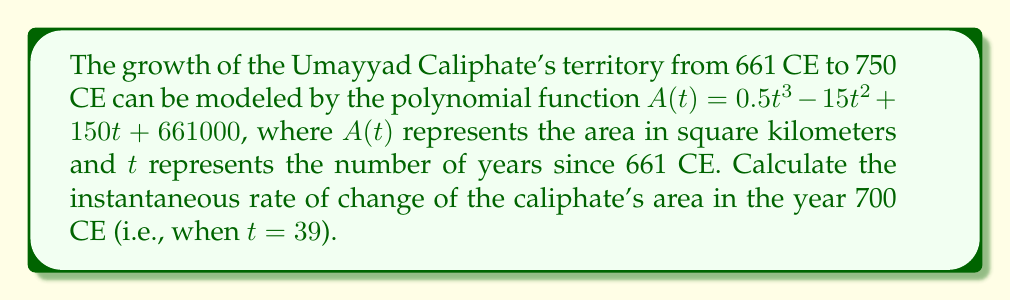Can you answer this question? To find the instantaneous rate of change at a specific point, we need to calculate the derivative of the function and evaluate it at the given point.

Step 1: Find the derivative of $A(t)$.
$$A'(t) = \frac{d}{dt}(0.5t^3 - 15t^2 + 150t + 661000)$$
$$A'(t) = 1.5t^2 - 30t + 150$$

Step 2: Evaluate $A'(t)$ at $t = 39$ (year 700 CE).
$$A'(39) = 1.5(39)^2 - 30(39) + 150$$
$$A'(39) = 1.5(1521) - 1170 + 150$$
$$A'(39) = 2281.5 - 1170 + 150$$
$$A'(39) = 1261.5$$

The instantaneous rate of change is 1261.5 square kilometers per year in 700 CE.
Answer: 1261.5 sq km/year 